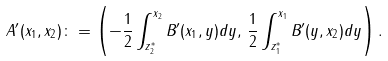<formula> <loc_0><loc_0><loc_500><loc_500>A ^ { \prime } ( x _ { 1 } , x _ { 2 } ) \colon = \left ( - \frac { 1 } { 2 } \int _ { z ^ { * } _ { 2 } } ^ { x _ { 2 } } B ^ { \prime } ( x _ { 1 } , y ) d y , \, \frac { 1 } { 2 } \int _ { z ^ { * } _ { 1 } } ^ { x _ { 1 } } B ^ { \prime } ( y , x _ { 2 } ) d y \right ) .</formula> 